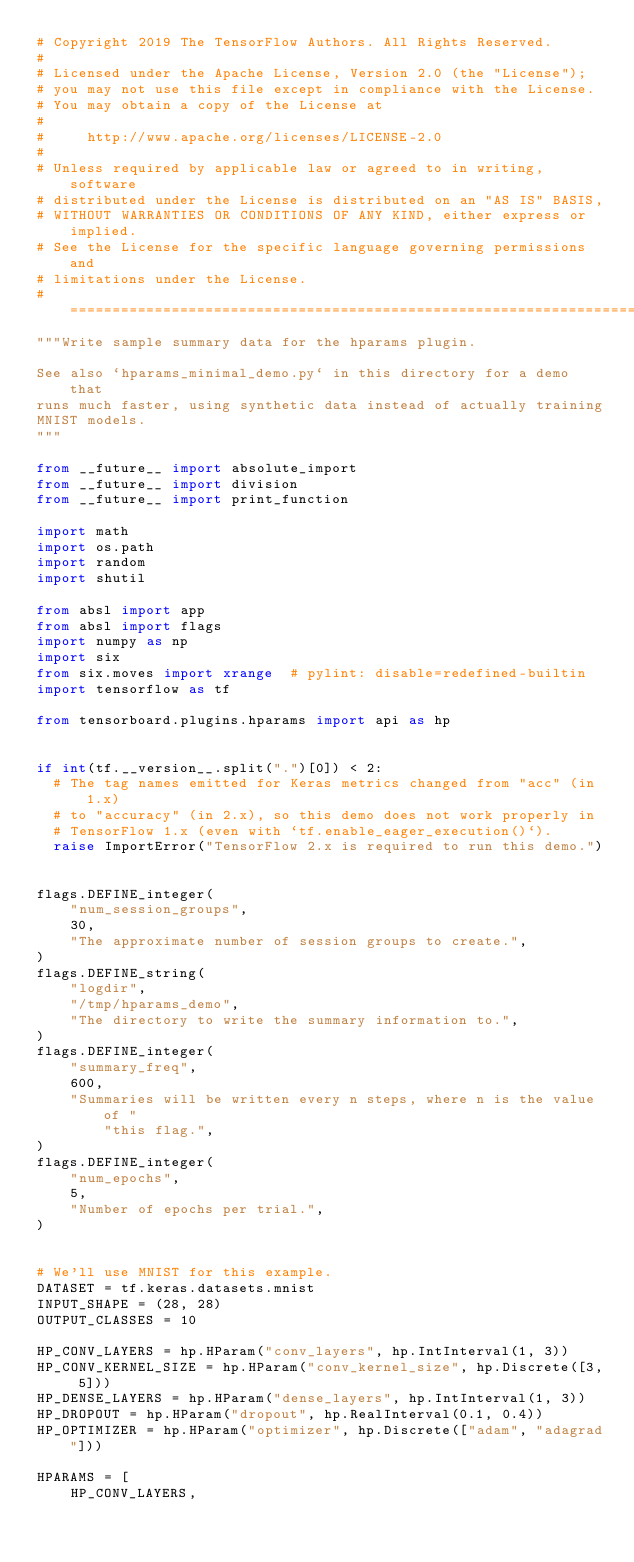<code> <loc_0><loc_0><loc_500><loc_500><_Python_># Copyright 2019 The TensorFlow Authors. All Rights Reserved.
#
# Licensed under the Apache License, Version 2.0 (the "License");
# you may not use this file except in compliance with the License.
# You may obtain a copy of the License at
#
#     http://www.apache.org/licenses/LICENSE-2.0
#
# Unless required by applicable law or agreed to in writing, software
# distributed under the License is distributed on an "AS IS" BASIS,
# WITHOUT WARRANTIES OR CONDITIONS OF ANY KIND, either express or implied.
# See the License for the specific language governing permissions and
# limitations under the License.
# ==============================================================================
"""Write sample summary data for the hparams plugin.

See also `hparams_minimal_demo.py` in this directory for a demo that
runs much faster, using synthetic data instead of actually training
MNIST models.
"""

from __future__ import absolute_import
from __future__ import division
from __future__ import print_function

import math
import os.path
import random
import shutil

from absl import app
from absl import flags
import numpy as np
import six
from six.moves import xrange  # pylint: disable=redefined-builtin
import tensorflow as tf

from tensorboard.plugins.hparams import api as hp


if int(tf.__version__.split(".")[0]) < 2:
  # The tag names emitted for Keras metrics changed from "acc" (in 1.x)
  # to "accuracy" (in 2.x), so this demo does not work properly in
  # TensorFlow 1.x (even with `tf.enable_eager_execution()`).
  raise ImportError("TensorFlow 2.x is required to run this demo.")


flags.DEFINE_integer(
    "num_session_groups",
    30,
    "The approximate number of session groups to create.",
)
flags.DEFINE_string(
    "logdir",
    "/tmp/hparams_demo",
    "The directory to write the summary information to.",
)
flags.DEFINE_integer(
    "summary_freq",
    600,
    "Summaries will be written every n steps, where n is the value of "
        "this flag.",
)
flags.DEFINE_integer(
    "num_epochs",
    5,
    "Number of epochs per trial.",
)


# We'll use MNIST for this example.
DATASET = tf.keras.datasets.mnist
INPUT_SHAPE = (28, 28)
OUTPUT_CLASSES = 10

HP_CONV_LAYERS = hp.HParam("conv_layers", hp.IntInterval(1, 3))
HP_CONV_KERNEL_SIZE = hp.HParam("conv_kernel_size", hp.Discrete([3, 5]))
HP_DENSE_LAYERS = hp.HParam("dense_layers", hp.IntInterval(1, 3))
HP_DROPOUT = hp.HParam("dropout", hp.RealInterval(0.1, 0.4))
HP_OPTIMIZER = hp.HParam("optimizer", hp.Discrete(["adam", "adagrad"]))

HPARAMS = [
    HP_CONV_LAYERS,</code> 